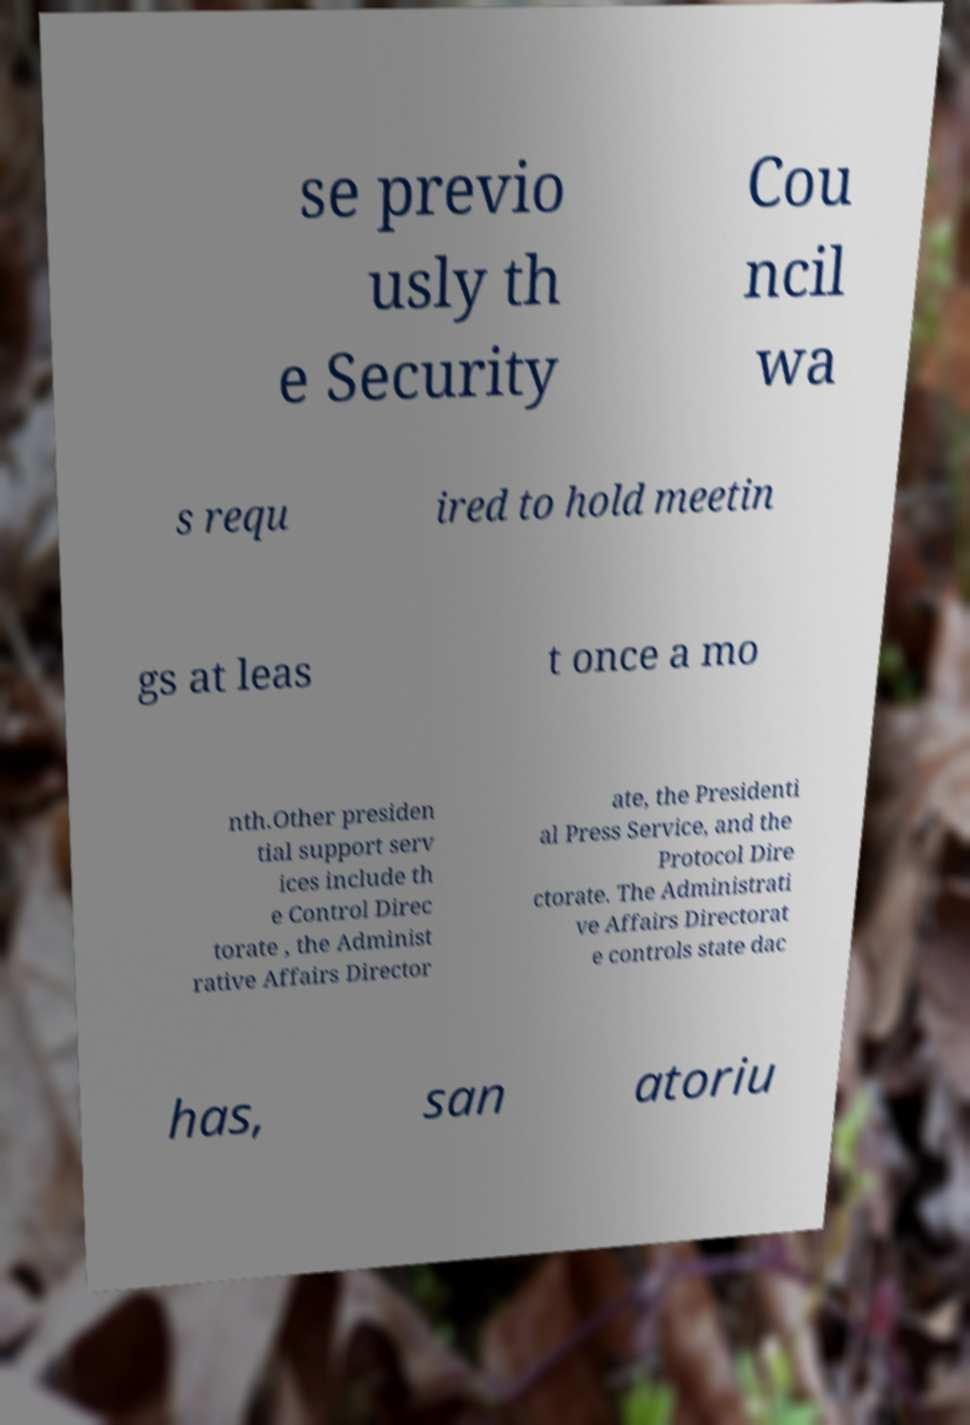There's text embedded in this image that I need extracted. Can you transcribe it verbatim? se previo usly th e Security Cou ncil wa s requ ired to hold meetin gs at leas t once a mo nth.Other presiden tial support serv ices include th e Control Direc torate , the Administ rative Affairs Director ate, the Presidenti al Press Service, and the Protocol Dire ctorate. The Administrati ve Affairs Directorat e controls state dac has, san atoriu 